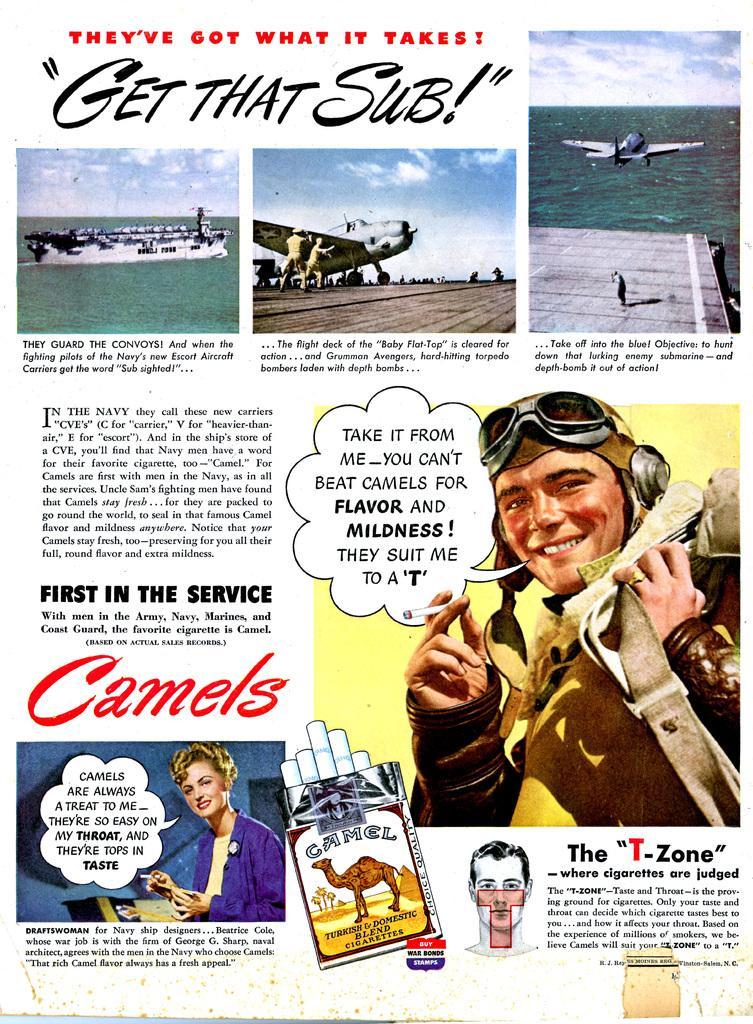Can you describe this image briefly? In this picture I can see there is a image of a man, he is wearing a cap, glasses and smiling. There is another image of a woman at left side bottom, she is holding a cigar and smiling. There is a ship sailing on the water, there is a aircraft image, two people are standing at the aircraft and there is another image of aircraft flying and the sky is clear. 